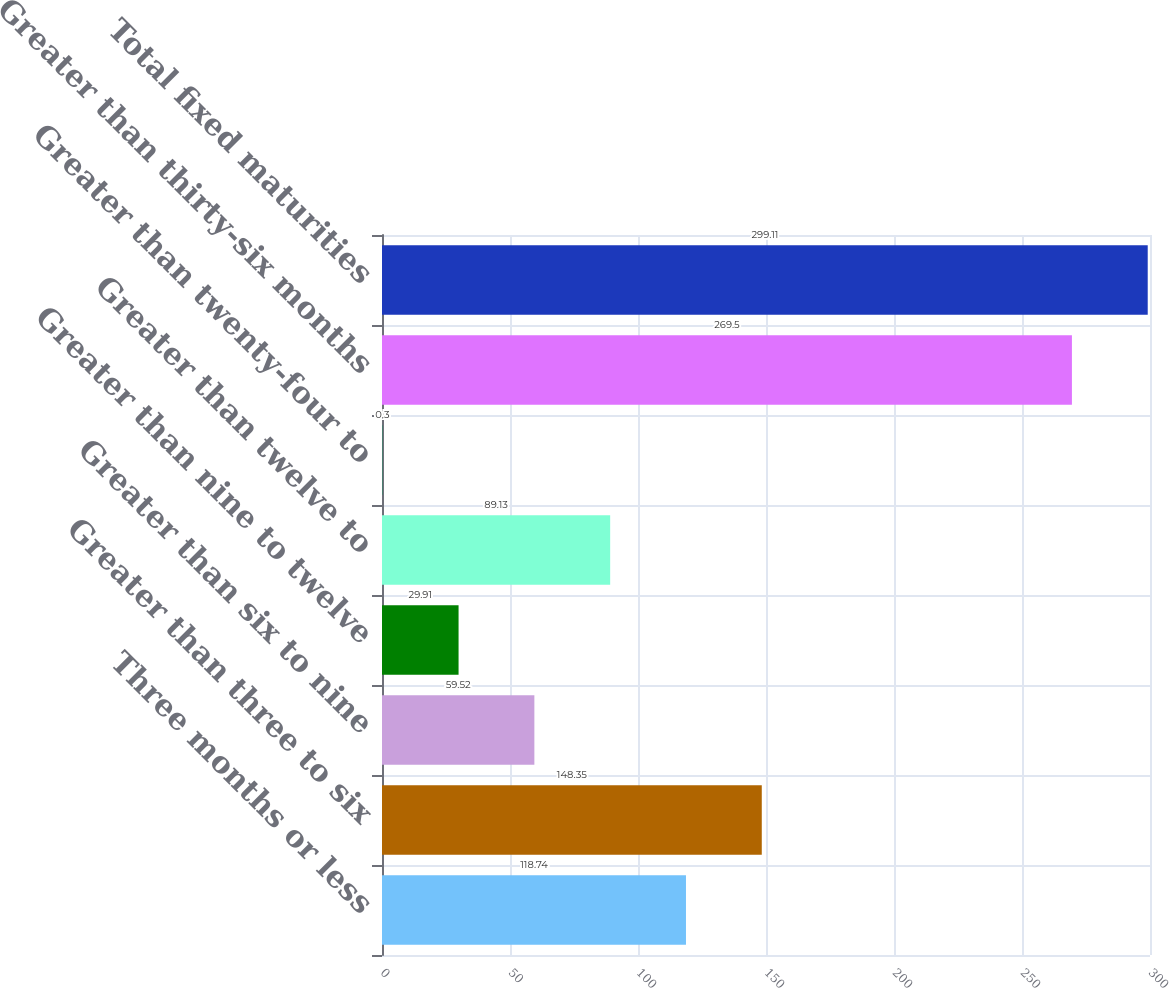<chart> <loc_0><loc_0><loc_500><loc_500><bar_chart><fcel>Three months or less<fcel>Greater than three to six<fcel>Greater than six to nine<fcel>Greater than nine to twelve<fcel>Greater than twelve to<fcel>Greater than twenty-four to<fcel>Greater than thirty-six months<fcel>Total fixed maturities<nl><fcel>118.74<fcel>148.35<fcel>59.52<fcel>29.91<fcel>89.13<fcel>0.3<fcel>269.5<fcel>299.11<nl></chart> 